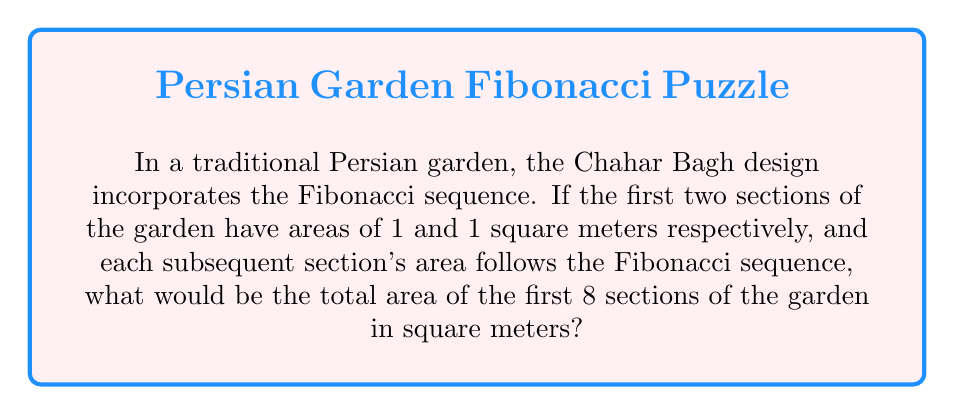Solve this math problem. Let's approach this step-by-step:

1) First, recall the Fibonacci sequence: Each number is the sum of the two preceding ones. It starts with 1, 1, and continues as 1, 1, 2, 3, 5, 8, 13, 21, ...

2) In this garden, the areas of the first 8 sections follow this sequence:
   Section 1: 1 m²
   Section 2: 1 m²
   Section 3: 2 m²
   Section 4: 3 m²
   Section 5: 5 m²
   Section 6: 8 m²
   Section 7: 13 m²
   Section 8: 21 m²

3) To find the total area, we need to sum these values:

   $$\text{Total Area} = 1 + 1 + 2 + 3 + 5 + 8 + 13 + 21$$

4) Let's add these numbers:
   $$1 + 1 = 2$$
   $$2 + 2 = 4$$
   $$4 + 3 = 7$$
   $$7 + 5 = 12$$
   $$12 + 8 = 20$$
   $$20 + 13 = 33$$
   $$33 + 21 = 54$$

5) Therefore, the total area of the first 8 sections is 54 square meters.
Answer: 54 m² 